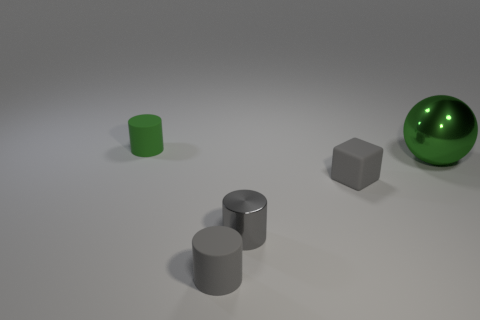Add 2 small metal things. How many objects exist? 7 Subtract all cubes. How many objects are left? 4 Add 5 yellow matte spheres. How many yellow matte spheres exist? 5 Subtract 0 blue blocks. How many objects are left? 5 Subtract all spheres. Subtract all tiny green matte cylinders. How many objects are left? 3 Add 3 gray metallic things. How many gray metallic things are left? 4 